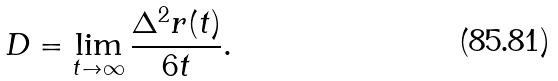Convert formula to latex. <formula><loc_0><loc_0><loc_500><loc_500>D = \lim _ { t \to \infty } \frac { \Delta ^ { 2 } r ( t ) } { 6 t } .</formula> 